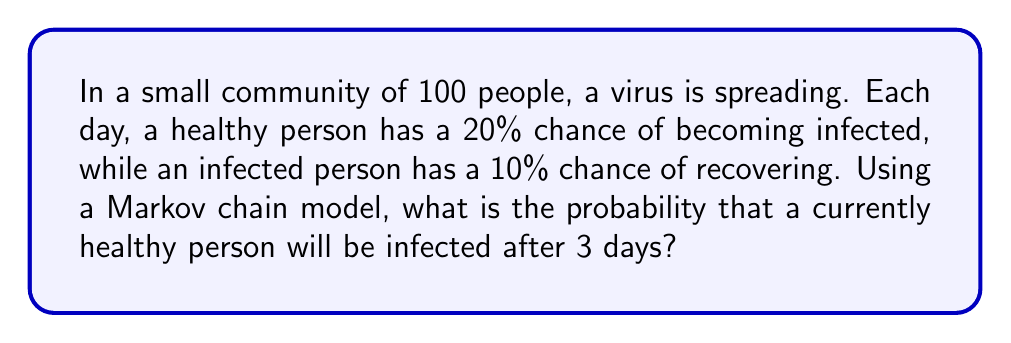Solve this math problem. Let's approach this step-by-step using a Markov chain model:

1) First, we need to define our states:
   State 0: Healthy
   State 1: Infected

2) Now, let's create the transition matrix P:

   $$P = \begin{bmatrix}
   0.8 & 0.2 \\
   0.1 & 0.9
   \end{bmatrix}$$

   Where:
   - P[0,0] = 0.8 is the probability of staying healthy
   - P[0,1] = 0.2 is the probability of becoming infected
   - P[1,0] = 0.1 is the probability of recovering
   - P[1,1] = 0.9 is the probability of staying infected

3) We start with a healthy person, so our initial state vector is:

   $$v_0 = \begin{bmatrix} 1 \\ 0 \end{bmatrix}$$

4) To find the state after 3 days, we need to multiply the initial state by the transition matrix 3 times:

   $$v_3 = P^3 \cdot v_0$$

5) Let's calculate $P^3$:

   $$P^2 = \begin{bmatrix}
   0.8 & 0.2 \\
   0.1 & 0.9
   \end{bmatrix} \cdot \begin{bmatrix}
   0.8 & 0.2 \\
   0.1 & 0.9
   \end{bmatrix} = \begin{bmatrix}
   0.66 & 0.34 \\
   0.17 & 0.83
   \end{bmatrix}$$

   $$P^3 = P \cdot P^2 = \begin{bmatrix}
   0.8 & 0.2 \\
   0.1 & 0.9
   \end{bmatrix} \cdot \begin{bmatrix}
   0.66 & 0.34 \\
   0.17 & 0.83
   \end{bmatrix} = \begin{bmatrix}
   0.562 & 0.438 \\
   0.223 & 0.777
   \end{bmatrix}$$

6) Now, let's multiply $P^3$ by $v_0$:

   $$v_3 = P^3 \cdot v_0 = \begin{bmatrix}
   0.562 & 0.438 \\
   0.223 & 0.777
   \end{bmatrix} \cdot \begin{bmatrix}
   1 \\
   0
   \end{bmatrix} = \begin{bmatrix}
   0.562 \\
   0.223
   \end{bmatrix}$$

7) The second element of $v_3$ (0.438) represents the probability of being infected after 3 days.
Answer: 0.438 